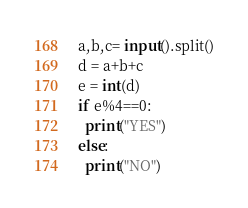Convert code to text. <code><loc_0><loc_0><loc_500><loc_500><_Python_>a,b,c= input().split()
d = a+b+c
e = int(d)
if e%4==0:
  print("YES")
else:
  print("NO")</code> 